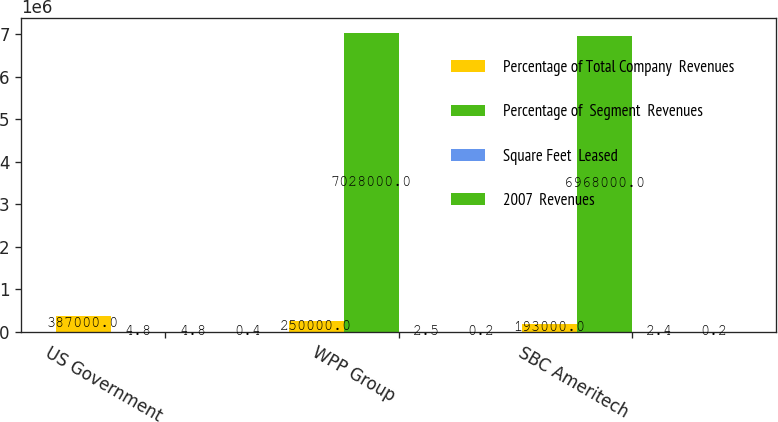<chart> <loc_0><loc_0><loc_500><loc_500><stacked_bar_chart><ecel><fcel>US Government<fcel>WPP Group<fcel>SBC Ameritech<nl><fcel>Percentage of Total Company  Revenues<fcel>387000<fcel>250000<fcel>193000<nl><fcel>Percentage of  Segment  Revenues<fcel>4.8<fcel>7.028e+06<fcel>6.968e+06<nl><fcel>Square Feet  Leased<fcel>4.8<fcel>2.5<fcel>2.4<nl><fcel>2007  Revenues<fcel>0.4<fcel>0.2<fcel>0.2<nl></chart> 